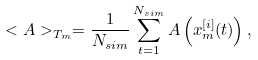<formula> <loc_0><loc_0><loc_500><loc_500>< A > _ { T _ { m } } = \frac { 1 } { N _ { s i m } } \sum _ { t = 1 } ^ { N _ { s i m } } A \left ( x _ { m } ^ { [ i ] } ( t ) \right ) ,</formula> 